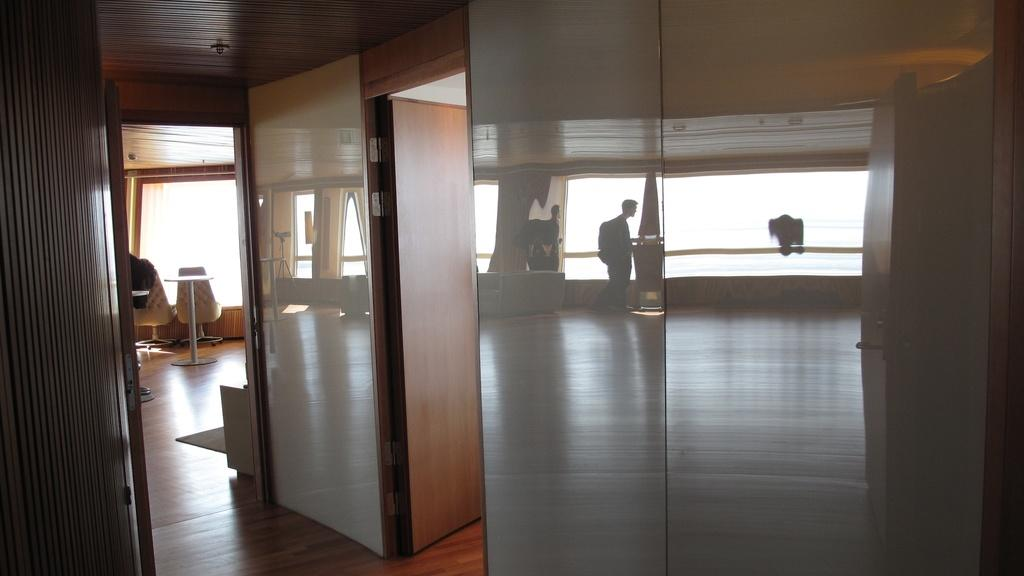What type of surface is visible in the image? There is a floor in the image. What piece of furniture is present in the image? There is a standing table in the image. How many chairs are in the image? There are four chairs in the image. Can you describe the reflection in the image? There is a reflection of a person in the image. What type of jewel is the person wearing in the image? There is no information about any jewelry in the image, as the focus is on the reflection of a person. 